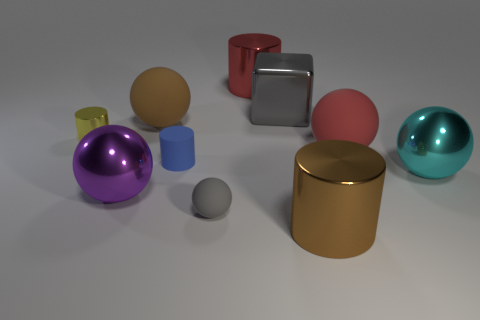There is a large metal cylinder right of the big gray thing; does it have the same color as the metal ball to the right of the brown metal thing?
Your answer should be very brief. No. Is there anything else that has the same material as the cyan thing?
Give a very brief answer. Yes. What size is the brown rubber thing that is the same shape as the big purple shiny object?
Provide a succinct answer. Large. There is a big cyan thing; are there any red metallic things on the left side of it?
Provide a succinct answer. Yes. Are there the same number of blocks in front of the purple metal sphere and things?
Give a very brief answer. No. Are there any gray things to the right of the red thing behind the large rubber thing in front of the tiny yellow cylinder?
Offer a very short reply. Yes. What is the big red sphere made of?
Provide a succinct answer. Rubber. What number of other objects are the same shape as the blue matte object?
Make the answer very short. 3. Is the shape of the blue rubber thing the same as the small yellow object?
Give a very brief answer. Yes. How many objects are either matte things in front of the brown rubber object or balls behind the large red rubber object?
Make the answer very short. 4. 